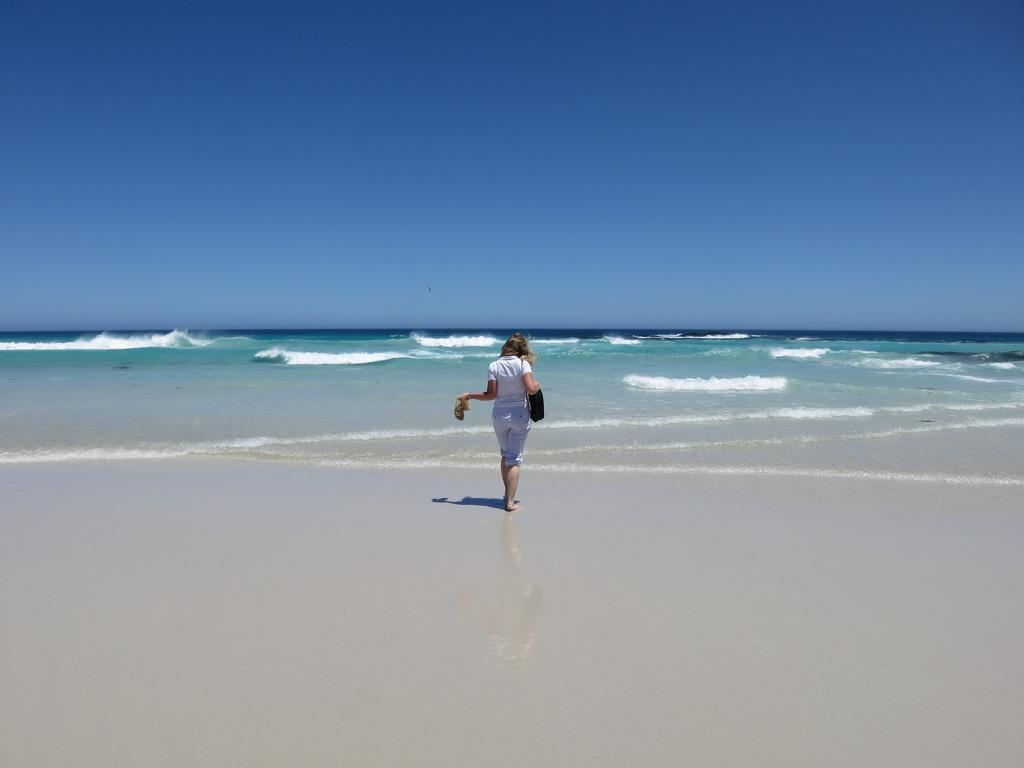Who is present in the image? There is a woman in the image. What natural feature can be seen in the image? Water waves are visible in the image. What is visible at the top of the image? The sky is visible at the top of the image. What type of beef is being served by the servant in the image? There is no servant or beef present in the image. How much water is visible in the image? The image does not show a specific amount of water; it only shows water waves. 